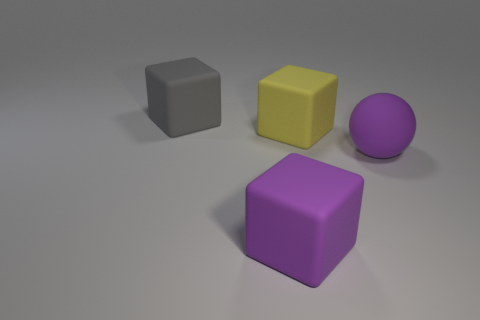Add 2 big yellow rubber cylinders. How many objects exist? 6 Subtract 1 cubes. How many cubes are left? 2 Subtract all big matte objects. Subtract all tiny metal objects. How many objects are left? 0 Add 3 large matte balls. How many large matte balls are left? 4 Add 4 rubber blocks. How many rubber blocks exist? 7 Subtract 0 brown cylinders. How many objects are left? 4 Subtract all blocks. How many objects are left? 1 Subtract all purple blocks. Subtract all red balls. How many blocks are left? 2 Subtract all brown cylinders. How many yellow blocks are left? 1 